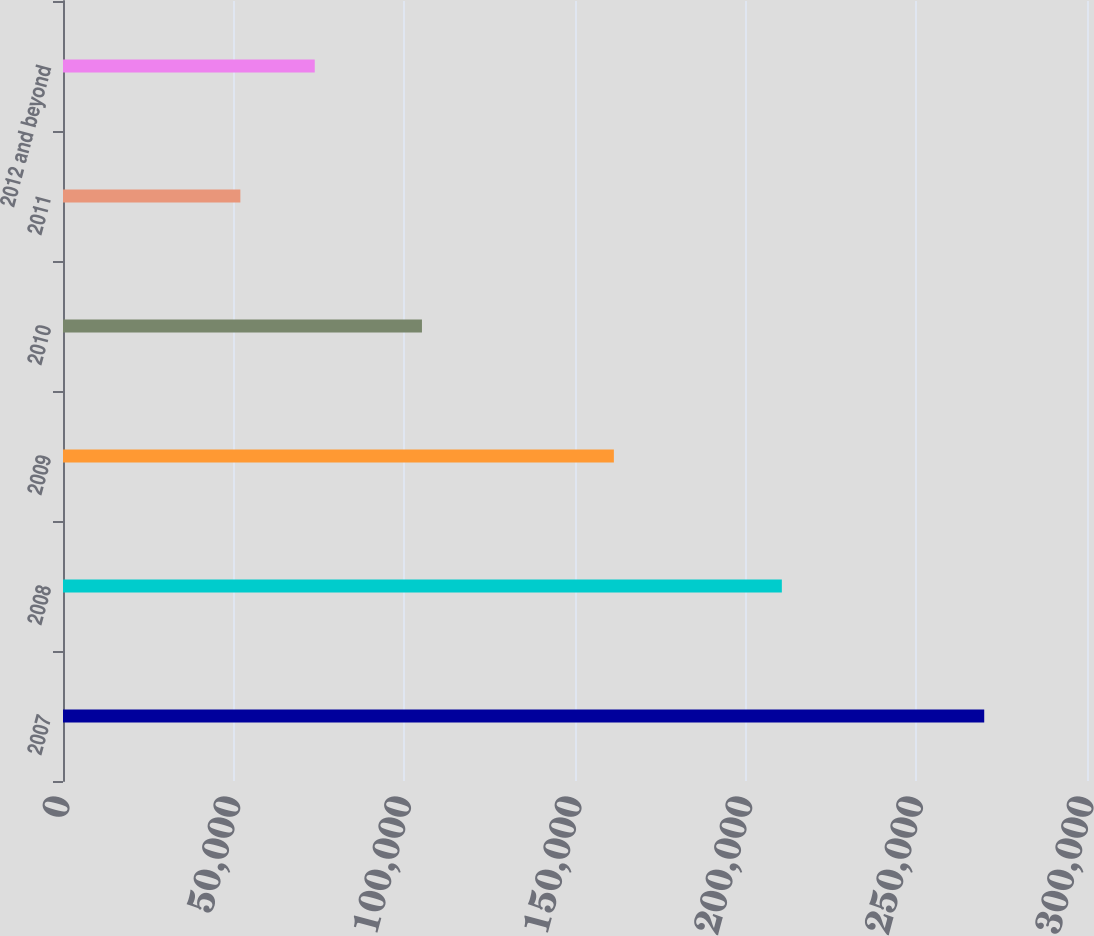Convert chart. <chart><loc_0><loc_0><loc_500><loc_500><bar_chart><fcel>2007<fcel>2008<fcel>2009<fcel>2010<fcel>2011<fcel>2012 and beyond<nl><fcel>269890<fcel>210596<fcel>161388<fcel>105163<fcel>51960<fcel>73753<nl></chart> 